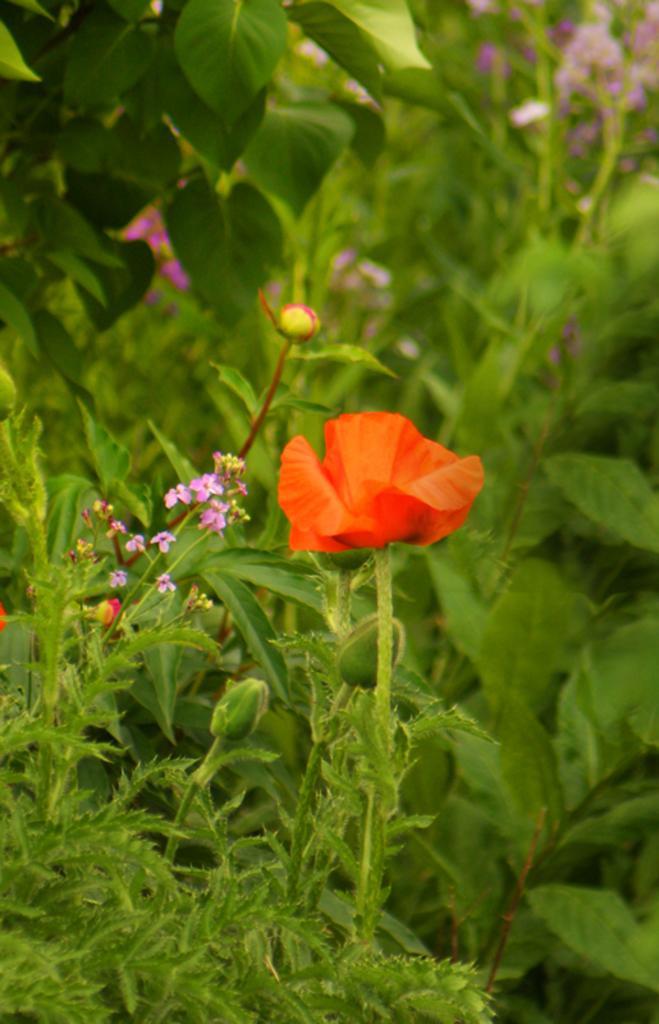In one or two sentences, can you explain what this image depicts? In this picture, we see the plants or trees which has the flowers and the buds. These flowers are in red and violet color. In the background, we see the plants and the flowers in violet color. This picture is blurred in the background. 